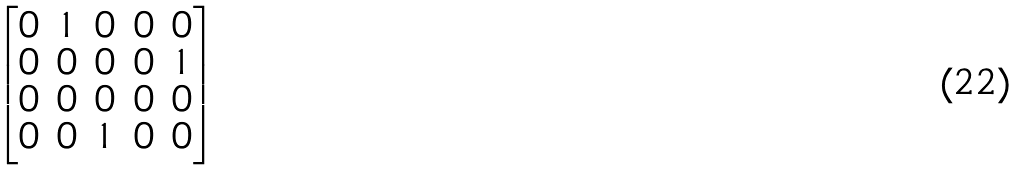<formula> <loc_0><loc_0><loc_500><loc_500>\begin{bmatrix} 0 & 1 & 0 & 0 & 0 \\ 0 & 0 & 0 & 0 & 1 \\ 0 & 0 & 0 & 0 & 0 \\ 0 & 0 & 1 & 0 & 0 \\ \end{bmatrix}</formula> 